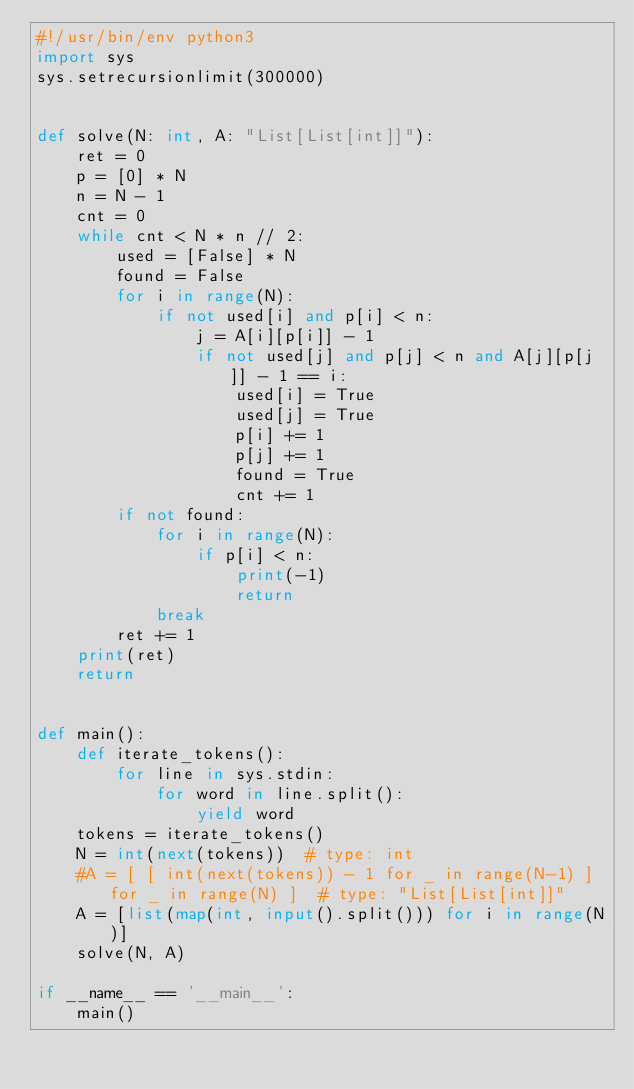Convert code to text. <code><loc_0><loc_0><loc_500><loc_500><_Python_>#!/usr/bin/env python3
import sys
sys.setrecursionlimit(300000)


def solve(N: int, A: "List[List[int]]"):
    ret = 0
    p = [0] * N
    n = N - 1
    cnt = 0
    while cnt < N * n // 2:
        used = [False] * N
        found = False
        for i in range(N):
            if not used[i] and p[i] < n:
                j = A[i][p[i]] - 1
                if not used[j] and p[j] < n and A[j][p[j]] - 1 == i:
                    used[i] = True
                    used[j] = True
                    p[i] += 1
                    p[j] += 1
                    found = True
                    cnt += 1
        if not found:
            for i in range(N):
                if p[i] < n:
                    print(-1)
                    return
            break
        ret += 1
    print(ret)
    return


def main():
    def iterate_tokens():
        for line in sys.stdin:
            for word in line.split():
                yield word
    tokens = iterate_tokens()
    N = int(next(tokens))  # type: int
    #A = [ [ int(next(tokens)) - 1 for _ in range(N-1) ] for _ in range(N) ]  # type: "List[List[int]]"
    A = [list(map(int, input().split())) for i in range(N)]
    solve(N, A)

if __name__ == '__main__':
    main()
</code> 